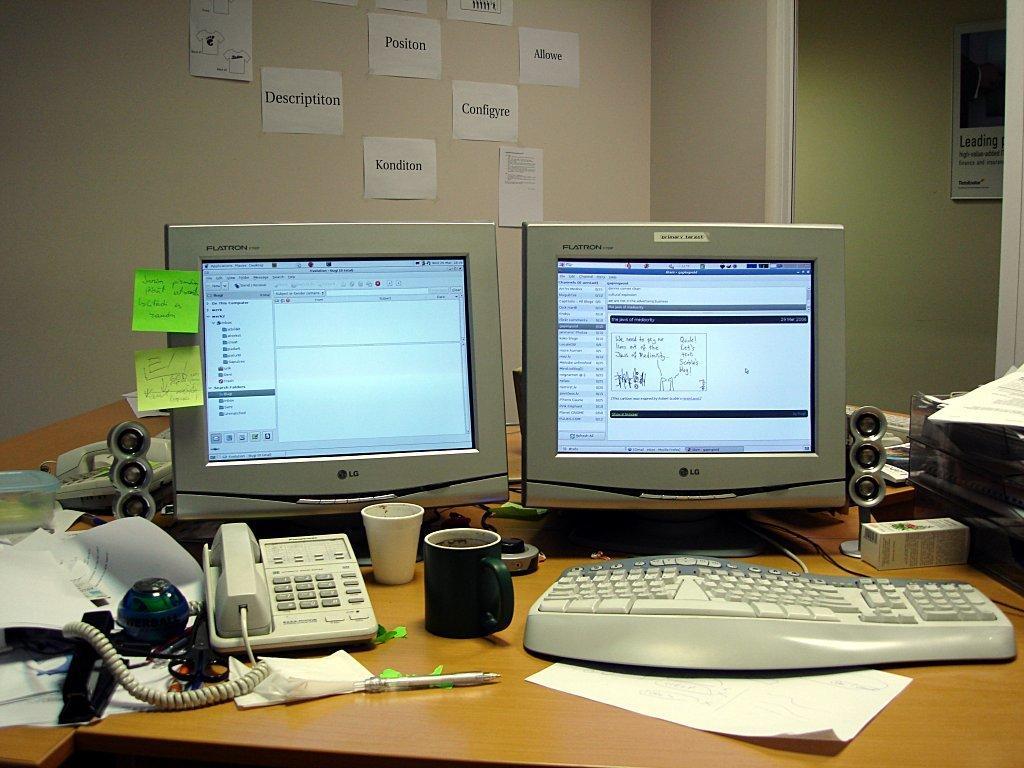In one or two sentences, can you explain what this image depicts? In this image there are monitors ,keyboard, cup, glass, land line phone, cables, speakers, boxes, pen , paper arranged in a table and in back ground there are papers and frame attached to wall. 